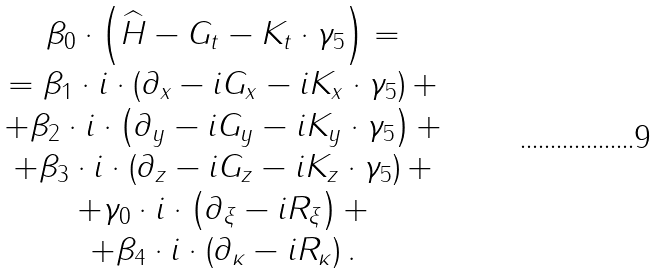Convert formula to latex. <formula><loc_0><loc_0><loc_500><loc_500>\begin{array} { c } \beta _ { 0 } \cdot \left ( \widehat { H } - G _ { t } - K _ { t } \cdot \gamma _ { 5 } \right ) = \\ = \beta _ { 1 } \cdot i \cdot \left ( \partial _ { x } - i G _ { x } - i K _ { x } \cdot \gamma _ { 5 } \right ) + \\ + \beta _ { 2 } \cdot i \cdot \left ( \partial _ { y } - i G _ { y } - i K _ { y } \cdot \gamma _ { 5 } \right ) + \\ + \beta _ { 3 } \cdot i \cdot \left ( \partial _ { z } - i G _ { z } - i K _ { z } \cdot \gamma _ { 5 } \right ) + \\ + \gamma _ { 0 } \cdot i \cdot \left ( \partial _ { \xi } - i R _ { \xi } \right ) + \\ + \beta _ { 4 } \cdot i \cdot \left ( \partial _ { \kappa } - i R _ { \kappa } \right ) . \end{array}</formula> 